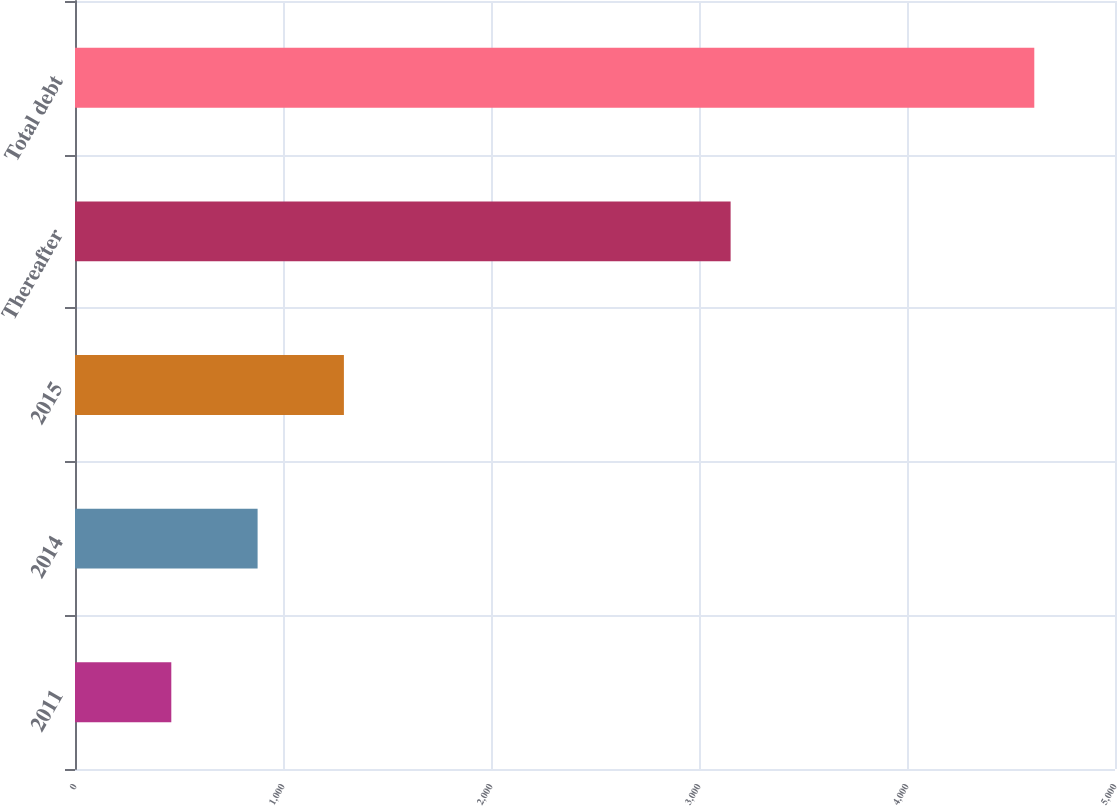Convert chart. <chart><loc_0><loc_0><loc_500><loc_500><bar_chart><fcel>2011<fcel>2014<fcel>2015<fcel>Thereafter<fcel>Total debt<nl><fcel>463<fcel>877.9<fcel>1292.8<fcel>3152<fcel>4612<nl></chart> 